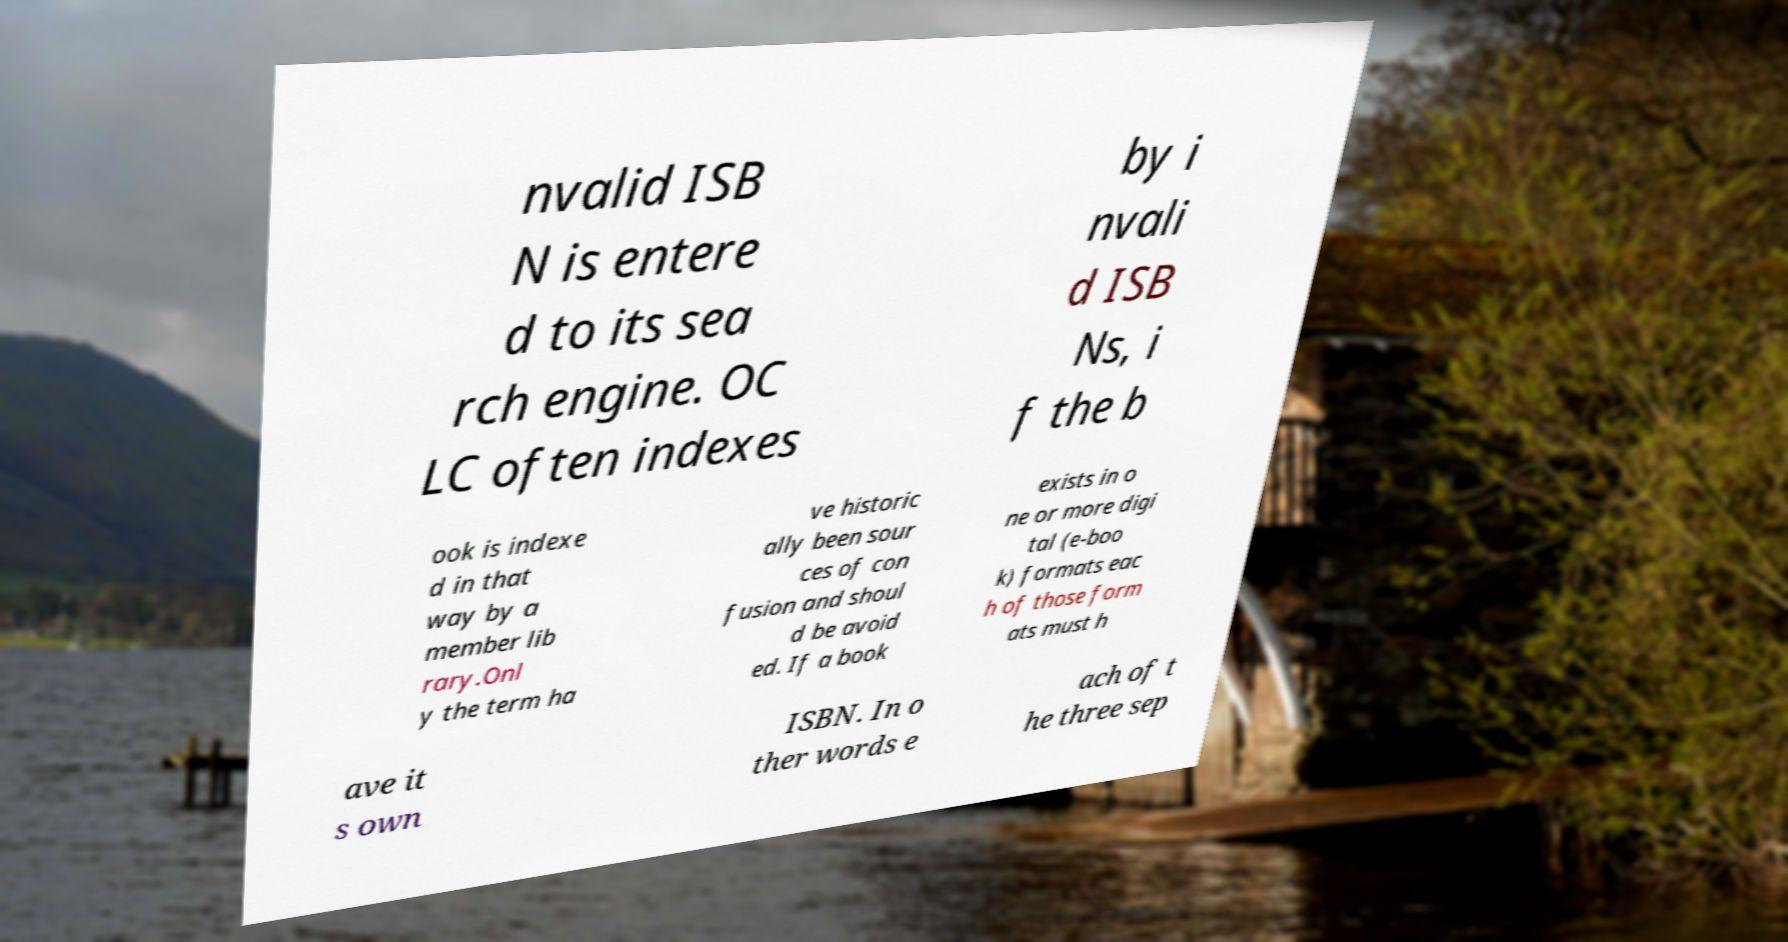Can you read and provide the text displayed in the image?This photo seems to have some interesting text. Can you extract and type it out for me? nvalid ISB N is entere d to its sea rch engine. OC LC often indexes by i nvali d ISB Ns, i f the b ook is indexe d in that way by a member lib rary.Onl y the term ha ve historic ally been sour ces of con fusion and shoul d be avoid ed. If a book exists in o ne or more digi tal (e-boo k) formats eac h of those form ats must h ave it s own ISBN. In o ther words e ach of t he three sep 